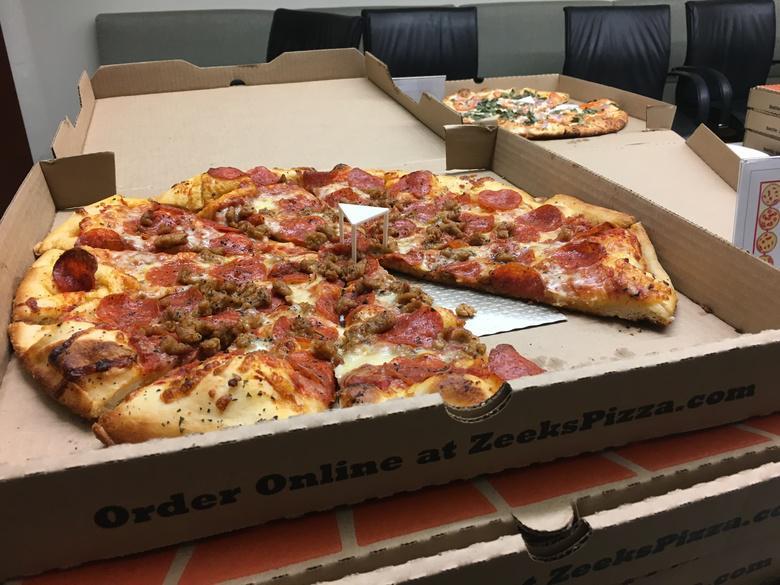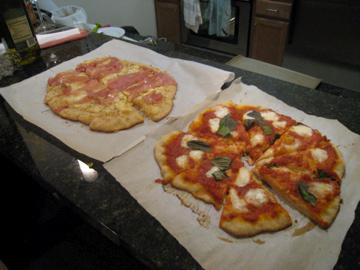The first image is the image on the left, the second image is the image on the right. Examine the images to the left and right. Is the description "A fork and knife have been placed next to the pizza in one of the pictures." accurate? Answer yes or no. No. The first image is the image on the left, the second image is the image on the right. Examine the images to the left and right. Is the description "Each image contains two roundish pizzas with no slices missing." accurate? Answer yes or no. No. 